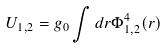Convert formula to latex. <formula><loc_0><loc_0><loc_500><loc_500>U _ { 1 , 2 } = g _ { 0 } \int d { r } \Phi _ { 1 , 2 } ^ { 4 } ( { r } )</formula> 